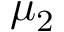<formula> <loc_0><loc_0><loc_500><loc_500>\mu _ { 2 }</formula> 